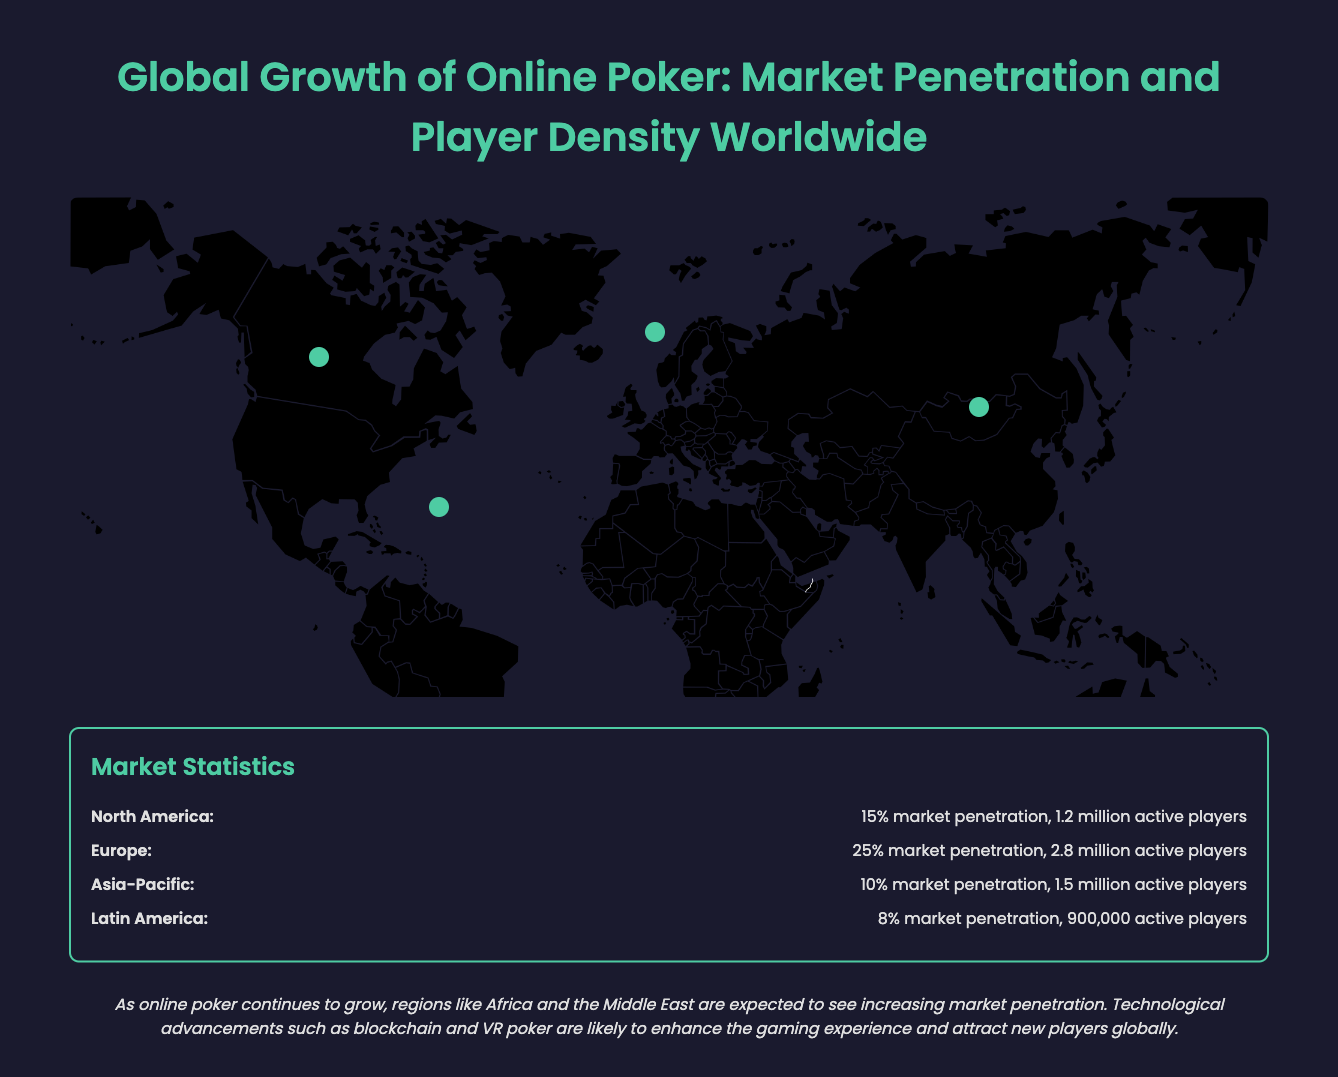What is the market penetration in North America? The market penetration in North America is explicitly stated in the document as 15%.
Answer: 15% How many active players are there in Europe? The document clearly indicates that Europe has 2.8 million active players.
Answer: 2.8 million Which region has the lowest market penetration? By comparing the market penetration statistics, Latin America has the lowest at 8%.
Answer: Latin America How many active players are in the Asia-Pacific region? The number of active players in the Asia-Pacific region is provided as 1.5 million.
Answer: 1.5 million Which region has the highest market penetration? Based on the document, Europe has the highest market penetration at 25%.
Answer: Europe What is a future prospect for online poker mentioned in the document? The document notes that technological advancements such as blockchain and VR poker are expected to enhance the gaming experience.
Answer: Technological advancements Which region is indicated to be a key market when clicked? Each region is labeled as a key market upon interaction in the document.
Answer: Clicked region What percentage of market penetration does Latin America have? Latin America’s market penetration is stated as 8%.
Answer: 8% How many active players does North America have? The number of active players in North America is mentioned as 1.2 million.
Answer: 1.2 million 